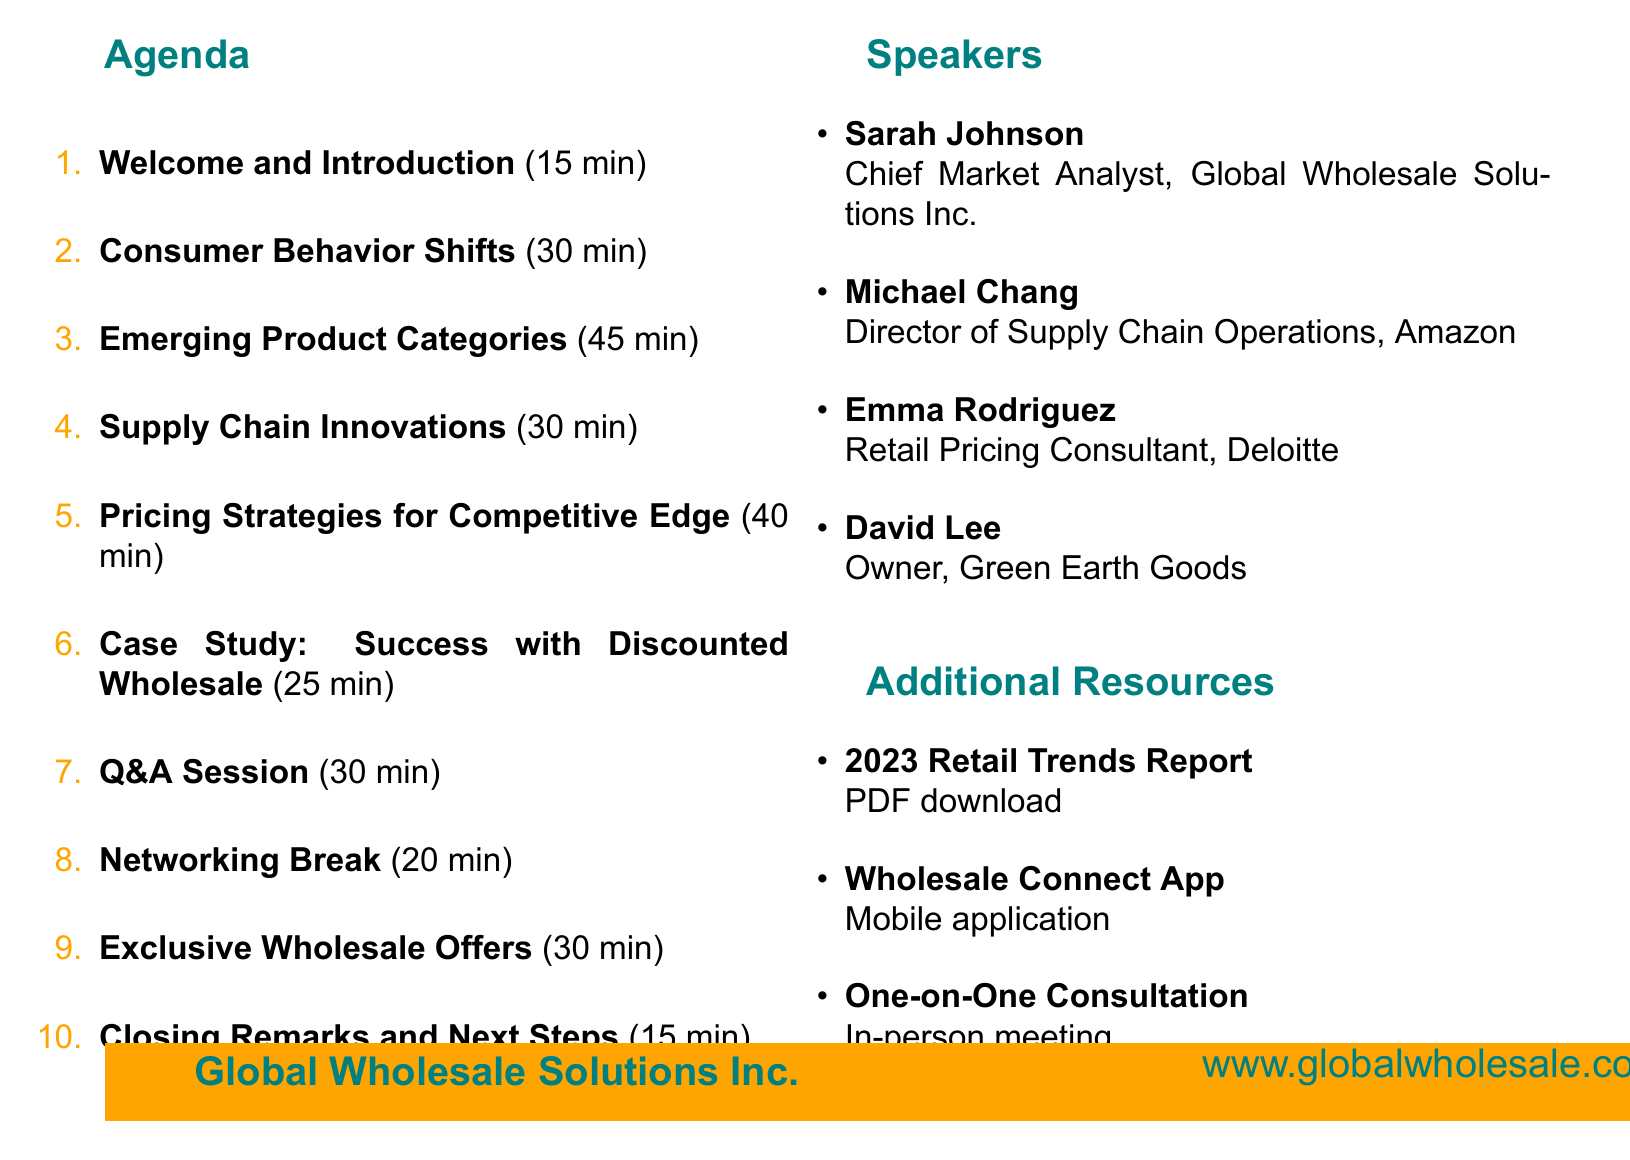What is the event name? The event name is stated clearly at the top of the document.
Answer: Bi-Annual Market Trend Forecast Presentation for Shop Owners Who is the host of the event? The host organization is mentioned right before the agenda section.
Answer: Global Wholesale Solutions Inc What is the date of the event? The date is explicitly provided in the document.
Answer: June 15, 2023 How long is the "Emerging Product Categories" presentation? The duration of each agenda item is listed alongside the title.
Answer: 45 minutes What is a key point discussed in the "Consumer Behavior Shifts" section? The key points are detailed under the respective agenda item.
Answer: Rise of e-commerce and its impact on brick-and-mortar stores Who is the speaker for the "Supply Chain Innovations" topic? The speaker's name and title are given in the speakers list.
Answer: Michael Chang What type of resource is the "Wholesale Connect App"? The resources provided have specified formats that indicate their type.
Answer: Mobile application What is the duration of the Q&A session? The duration for each segment is included in the agenda.
Answer: 30 minutes What shop is featured in the case study? The featured shop for the case study is mentioned directly in the agenda item description.
Answer: Green Earth Goods, Portland, OR 